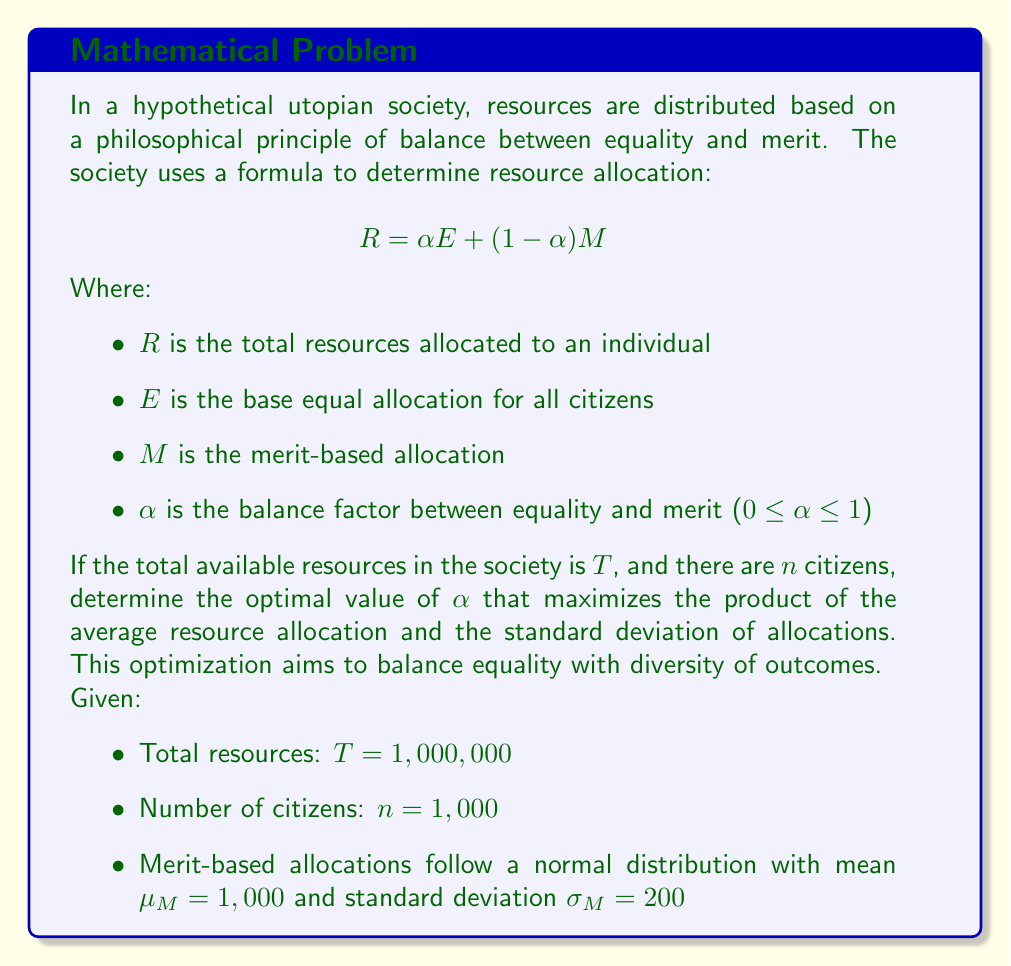Show me your answer to this math problem. To solve this problem, we need to follow these steps:

1) First, let's define the average resource allocation $\bar{R}$:

   $$ \bar{R} = \frac{T}{n} = \frac{1,000,000}{1,000} = 1,000 $$

2) Now, we need to express $E$ in terms of $\alpha$, $T$, $n$, and $\mu_M$:

   $$ T = n(\alpha E + (1-\alpha)\mu_M) $$
   $$ 1,000,000 = 1,000(\alpha E + (1-\alpha)1,000) $$
   $$ 1,000 = \alpha E + 1,000 - 1,000\alpha $$
   $$ \alpha E = 1,000\alpha $$
   $$ E = 1,000 $$

3) The standard deviation of $R$, which we'll call $\sigma_R$, can be expressed as:

   $$ \sigma_R = (1-\alpha)\sigma_M = 200(1-\alpha) $$

4) Our objective function to maximize is:

   $$ f(\alpha) = \bar{R} \cdot \sigma_R = 1,000 \cdot 200(1-\alpha) = 200,000(1-\alpha) $$

5) To find the maximum of this function, we differentiate and set to zero:

   $$ \frac{df}{d\alpha} = -200,000 = 0 $$

6) This equation is always negative, meaning our function is always decreasing. Therefore, the maximum occurs at the lowest possible value of $\alpha$, which is 0.
Answer: The optimal value of $\alpha$ is 0, which means the utopian society should allocate resources entirely based on merit to maximize the product of average allocation and allocation diversity. However, this mathematical result conflicts with the philosophical principle of balancing equality and merit, highlighting the tension between mathematical optimization and ethical considerations in resource distribution. 